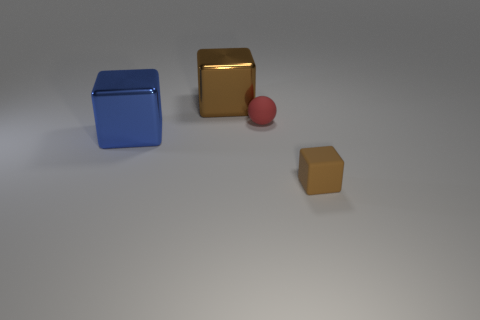What number of other objects are the same material as the large blue block?
Provide a short and direct response. 1. Is there any other thing that is the same size as the blue metal cube?
Keep it short and to the point. Yes. Is the number of large cyan shiny spheres greater than the number of blue objects?
Keep it short and to the point. No. There is a brown object that is behind the big thing to the left of the big brown metallic thing that is to the right of the blue metallic block; what is its size?
Your response must be concise. Large. There is a blue metal object; does it have the same size as the matte thing that is behind the small brown block?
Your answer should be compact. No. Is the number of small balls that are behind the large brown object less than the number of big gray blocks?
Provide a succinct answer. No. How many rubber things have the same color as the tiny rubber ball?
Provide a short and direct response. 0. Is the number of large cyan metallic cylinders less than the number of big brown metal objects?
Keep it short and to the point. Yes. Is the sphere made of the same material as the small brown block?
Your answer should be compact. Yes. What number of other objects are there of the same size as the matte ball?
Offer a terse response. 1. 